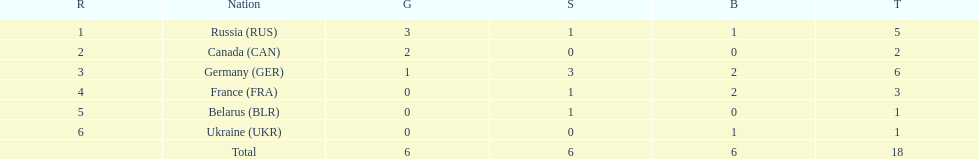Who had a larger total medal count, france or canada? France. 